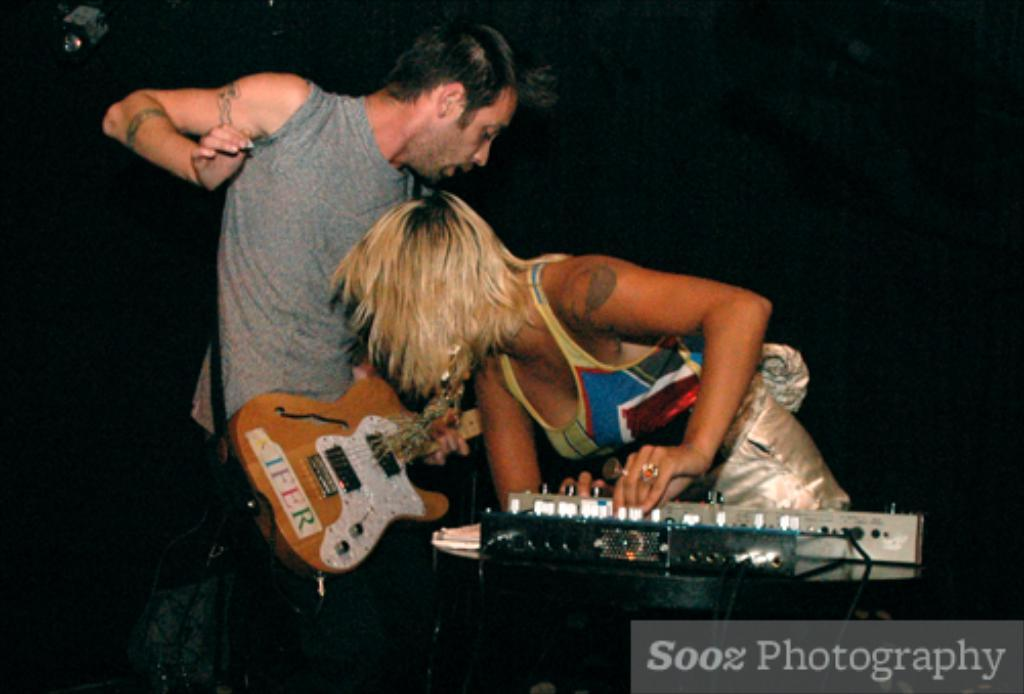How many people are present in the image? There are two people in the image. Can you describe the gender of the individuals? One of the people is a guy, and the other person is a girl. What are the people in the image doing? Both the guy and the girl are playing musical instruments. What type of plant is being used as a purpose for the trees in the image? There is no plant or trees mentioned in the image; it features two people playing musical instruments. 